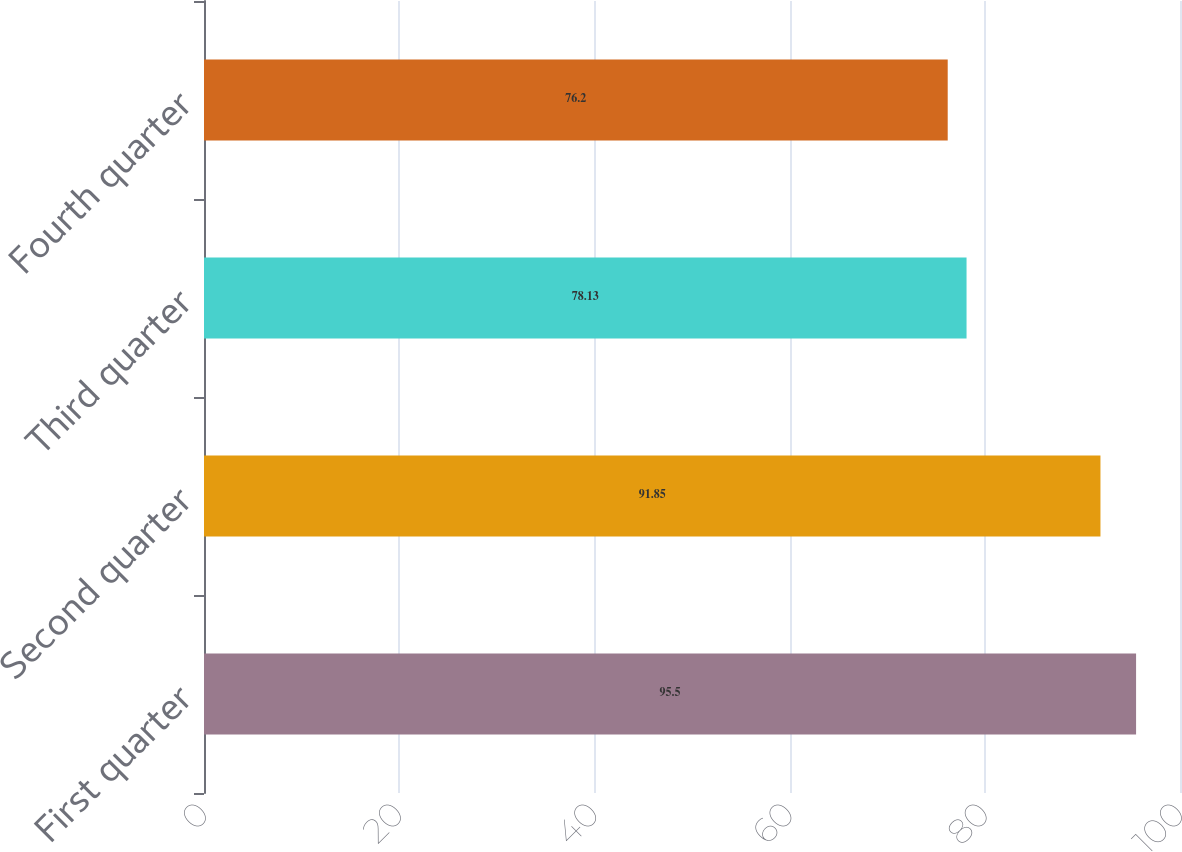Convert chart. <chart><loc_0><loc_0><loc_500><loc_500><bar_chart><fcel>First quarter<fcel>Second quarter<fcel>Third quarter<fcel>Fourth quarter<nl><fcel>95.5<fcel>91.85<fcel>78.13<fcel>76.2<nl></chart> 